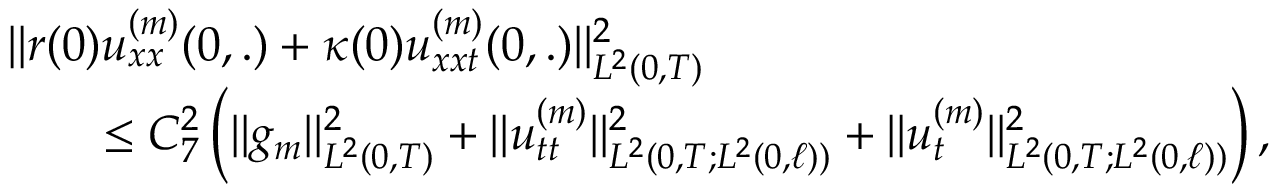<formula> <loc_0><loc_0><loc_500><loc_500>\begin{array} { r l r } { { \| r ( 0 ) u _ { x x } ^ { ( m ) } ( 0 , . ) + \kappa ( 0 ) u _ { x x t } ^ { ( m ) } ( 0 , . ) \| _ { L ^ { 2 } ( 0 , T ) } ^ { 2 } } } \\ & { \leq C _ { 7 } ^ { 2 } \left ( \| g _ { m } \| _ { L ^ { 2 } ( 0 , T ) } ^ { 2 } + \| u _ { t t } ^ { ( m ) } \| _ { L ^ { 2 } ( 0 , T ; L ^ { 2 } ( 0 , \ell ) ) } ^ { 2 } + \| u _ { t } ^ { ( m ) } \| _ { L ^ { 2 } ( 0 , T ; L ^ { 2 } ( 0 , \ell ) ) } ^ { 2 } \right ) , } \end{array}</formula> 